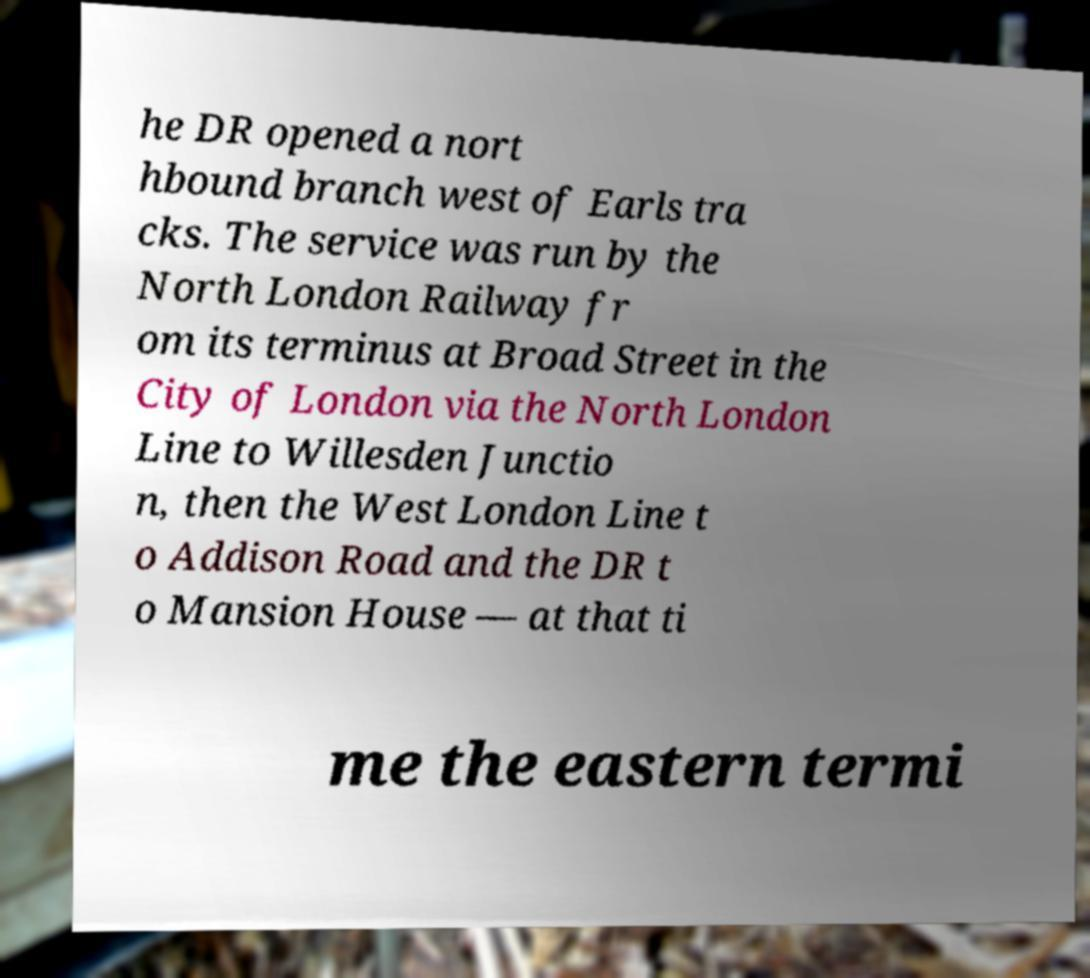Could you extract and type out the text from this image? he DR opened a nort hbound branch west of Earls tra cks. The service was run by the North London Railway fr om its terminus at Broad Street in the City of London via the North London Line to Willesden Junctio n, then the West London Line t o Addison Road and the DR t o Mansion House — at that ti me the eastern termi 